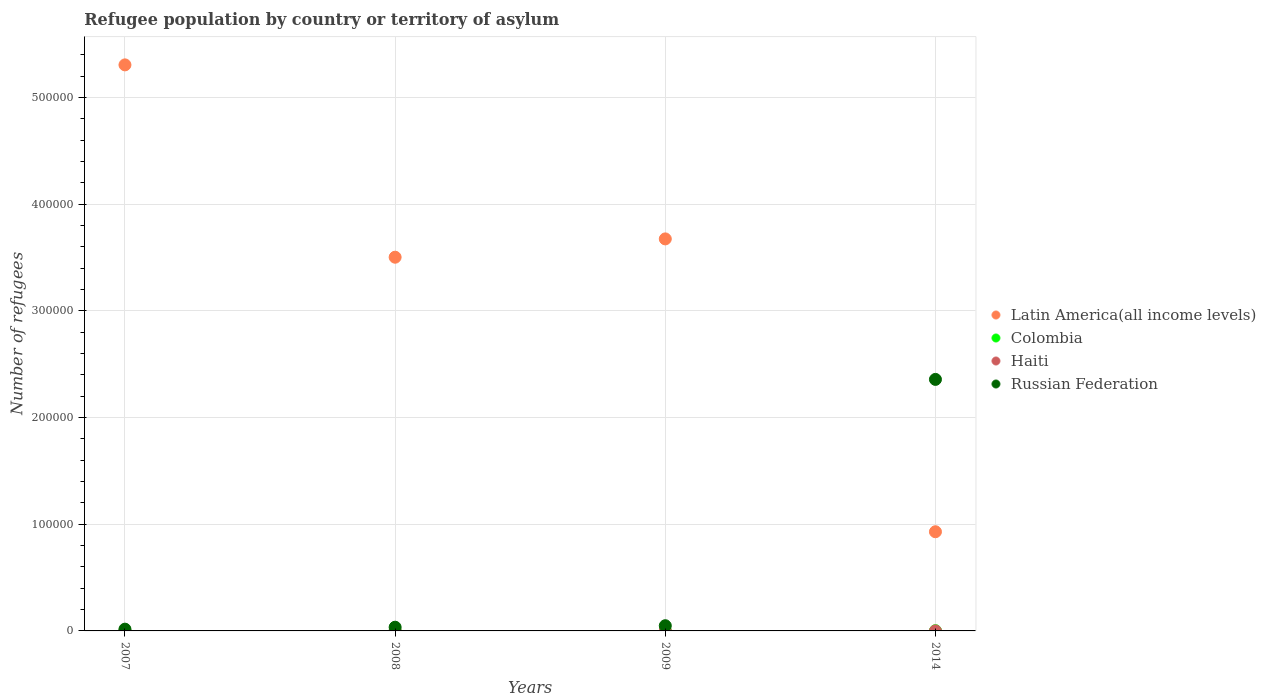How many different coloured dotlines are there?
Offer a very short reply. 4. What is the number of refugees in Latin America(all income levels) in 2008?
Ensure brevity in your answer.  3.50e+05. Across all years, what is the maximum number of refugees in Colombia?
Give a very brief answer. 213. In which year was the number of refugees in Haiti minimum?
Provide a short and direct response. 2007. What is the total number of refugees in Latin America(all income levels) in the graph?
Your response must be concise. 1.34e+06. What is the difference between the number of refugees in Colombia in 2007 and that in 2014?
Ensure brevity in your answer.  -45. What is the difference between the number of refugees in Colombia in 2008 and the number of refugees in Russian Federation in 2009?
Your answer should be very brief. -4710. What is the average number of refugees in Haiti per year?
Ensure brevity in your answer.  2.5. In the year 2007, what is the difference between the number of refugees in Latin America(all income levels) and number of refugees in Colombia?
Offer a very short reply. 5.30e+05. What is the ratio of the number of refugees in Colombia in 2008 to that in 2009?
Ensure brevity in your answer.  0.87. Is the number of refugees in Russian Federation in 2009 less than that in 2014?
Provide a succinct answer. Yes. What is the difference between the highest and the second highest number of refugees in Latin America(all income levels)?
Provide a succinct answer. 1.63e+05. What is the difference between the highest and the lowest number of refugees in Latin America(all income levels)?
Keep it short and to the point. 4.38e+05. In how many years, is the number of refugees in Russian Federation greater than the average number of refugees in Russian Federation taken over all years?
Make the answer very short. 1. Is the number of refugees in Colombia strictly less than the number of refugees in Latin America(all income levels) over the years?
Your response must be concise. Yes. How many dotlines are there?
Your answer should be compact. 4. Are the values on the major ticks of Y-axis written in scientific E-notation?
Your answer should be compact. No. How many legend labels are there?
Provide a succinct answer. 4. How are the legend labels stacked?
Offer a terse response. Vertical. What is the title of the graph?
Your response must be concise. Refugee population by country or territory of asylum. Does "Sri Lanka" appear as one of the legend labels in the graph?
Ensure brevity in your answer.  No. What is the label or title of the Y-axis?
Offer a very short reply. Number of refugees. What is the Number of refugees of Latin America(all income levels) in 2007?
Offer a terse response. 5.31e+05. What is the Number of refugees of Colombia in 2007?
Offer a very short reply. 168. What is the Number of refugees in Haiti in 2007?
Give a very brief answer. 1. What is the Number of refugees in Russian Federation in 2007?
Offer a very short reply. 1655. What is the Number of refugees in Latin America(all income levels) in 2008?
Your answer should be very brief. 3.50e+05. What is the Number of refugees of Colombia in 2008?
Make the answer very short. 170. What is the Number of refugees of Russian Federation in 2008?
Provide a succinct answer. 3479. What is the Number of refugees in Latin America(all income levels) in 2009?
Provide a succinct answer. 3.67e+05. What is the Number of refugees in Colombia in 2009?
Make the answer very short. 196. What is the Number of refugees of Russian Federation in 2009?
Make the answer very short. 4880. What is the Number of refugees in Latin America(all income levels) in 2014?
Offer a very short reply. 9.30e+04. What is the Number of refugees of Colombia in 2014?
Provide a succinct answer. 213. What is the Number of refugees in Haiti in 2014?
Make the answer very short. 3. What is the Number of refugees in Russian Federation in 2014?
Provide a succinct answer. 2.36e+05. Across all years, what is the maximum Number of refugees in Latin America(all income levels)?
Your answer should be compact. 5.31e+05. Across all years, what is the maximum Number of refugees of Colombia?
Make the answer very short. 213. Across all years, what is the maximum Number of refugees of Haiti?
Provide a succinct answer. 3. Across all years, what is the maximum Number of refugees in Russian Federation?
Your response must be concise. 2.36e+05. Across all years, what is the minimum Number of refugees in Latin America(all income levels)?
Provide a short and direct response. 9.30e+04. Across all years, what is the minimum Number of refugees of Colombia?
Offer a terse response. 168. Across all years, what is the minimum Number of refugees of Haiti?
Provide a short and direct response. 1. Across all years, what is the minimum Number of refugees of Russian Federation?
Keep it short and to the point. 1655. What is the total Number of refugees of Latin America(all income levels) in the graph?
Keep it short and to the point. 1.34e+06. What is the total Number of refugees in Colombia in the graph?
Your answer should be compact. 747. What is the total Number of refugees of Russian Federation in the graph?
Provide a short and direct response. 2.46e+05. What is the difference between the Number of refugees in Latin America(all income levels) in 2007 and that in 2008?
Make the answer very short. 1.80e+05. What is the difference between the Number of refugees in Haiti in 2007 and that in 2008?
Give a very brief answer. -2. What is the difference between the Number of refugees of Russian Federation in 2007 and that in 2008?
Make the answer very short. -1824. What is the difference between the Number of refugees of Latin America(all income levels) in 2007 and that in 2009?
Provide a succinct answer. 1.63e+05. What is the difference between the Number of refugees of Haiti in 2007 and that in 2009?
Offer a terse response. -2. What is the difference between the Number of refugees of Russian Federation in 2007 and that in 2009?
Make the answer very short. -3225. What is the difference between the Number of refugees in Latin America(all income levels) in 2007 and that in 2014?
Your answer should be compact. 4.38e+05. What is the difference between the Number of refugees of Colombia in 2007 and that in 2014?
Offer a very short reply. -45. What is the difference between the Number of refugees of Haiti in 2007 and that in 2014?
Your answer should be compact. -2. What is the difference between the Number of refugees in Russian Federation in 2007 and that in 2014?
Provide a succinct answer. -2.34e+05. What is the difference between the Number of refugees in Latin America(all income levels) in 2008 and that in 2009?
Keep it short and to the point. -1.72e+04. What is the difference between the Number of refugees of Haiti in 2008 and that in 2009?
Your answer should be compact. 0. What is the difference between the Number of refugees in Russian Federation in 2008 and that in 2009?
Make the answer very short. -1401. What is the difference between the Number of refugees in Latin America(all income levels) in 2008 and that in 2014?
Your answer should be very brief. 2.57e+05. What is the difference between the Number of refugees in Colombia in 2008 and that in 2014?
Offer a very short reply. -43. What is the difference between the Number of refugees of Russian Federation in 2008 and that in 2014?
Make the answer very short. -2.32e+05. What is the difference between the Number of refugees in Latin America(all income levels) in 2009 and that in 2014?
Provide a succinct answer. 2.74e+05. What is the difference between the Number of refugees in Colombia in 2009 and that in 2014?
Your response must be concise. -17. What is the difference between the Number of refugees in Russian Federation in 2009 and that in 2014?
Keep it short and to the point. -2.31e+05. What is the difference between the Number of refugees of Latin America(all income levels) in 2007 and the Number of refugees of Colombia in 2008?
Your answer should be very brief. 5.30e+05. What is the difference between the Number of refugees of Latin America(all income levels) in 2007 and the Number of refugees of Haiti in 2008?
Your answer should be very brief. 5.31e+05. What is the difference between the Number of refugees of Latin America(all income levels) in 2007 and the Number of refugees of Russian Federation in 2008?
Your answer should be very brief. 5.27e+05. What is the difference between the Number of refugees in Colombia in 2007 and the Number of refugees in Haiti in 2008?
Give a very brief answer. 165. What is the difference between the Number of refugees in Colombia in 2007 and the Number of refugees in Russian Federation in 2008?
Your response must be concise. -3311. What is the difference between the Number of refugees in Haiti in 2007 and the Number of refugees in Russian Federation in 2008?
Your response must be concise. -3478. What is the difference between the Number of refugees of Latin America(all income levels) in 2007 and the Number of refugees of Colombia in 2009?
Your response must be concise. 5.30e+05. What is the difference between the Number of refugees of Latin America(all income levels) in 2007 and the Number of refugees of Haiti in 2009?
Provide a succinct answer. 5.31e+05. What is the difference between the Number of refugees in Latin America(all income levels) in 2007 and the Number of refugees in Russian Federation in 2009?
Keep it short and to the point. 5.26e+05. What is the difference between the Number of refugees in Colombia in 2007 and the Number of refugees in Haiti in 2009?
Provide a short and direct response. 165. What is the difference between the Number of refugees of Colombia in 2007 and the Number of refugees of Russian Federation in 2009?
Your answer should be compact. -4712. What is the difference between the Number of refugees of Haiti in 2007 and the Number of refugees of Russian Federation in 2009?
Make the answer very short. -4879. What is the difference between the Number of refugees of Latin America(all income levels) in 2007 and the Number of refugees of Colombia in 2014?
Make the answer very short. 5.30e+05. What is the difference between the Number of refugees in Latin America(all income levels) in 2007 and the Number of refugees in Haiti in 2014?
Make the answer very short. 5.31e+05. What is the difference between the Number of refugees of Latin America(all income levels) in 2007 and the Number of refugees of Russian Federation in 2014?
Make the answer very short. 2.95e+05. What is the difference between the Number of refugees of Colombia in 2007 and the Number of refugees of Haiti in 2014?
Provide a short and direct response. 165. What is the difference between the Number of refugees in Colombia in 2007 and the Number of refugees in Russian Federation in 2014?
Offer a very short reply. -2.36e+05. What is the difference between the Number of refugees of Haiti in 2007 and the Number of refugees of Russian Federation in 2014?
Give a very brief answer. -2.36e+05. What is the difference between the Number of refugees of Latin America(all income levels) in 2008 and the Number of refugees of Colombia in 2009?
Ensure brevity in your answer.  3.50e+05. What is the difference between the Number of refugees of Latin America(all income levels) in 2008 and the Number of refugees of Haiti in 2009?
Provide a short and direct response. 3.50e+05. What is the difference between the Number of refugees of Latin America(all income levels) in 2008 and the Number of refugees of Russian Federation in 2009?
Ensure brevity in your answer.  3.45e+05. What is the difference between the Number of refugees of Colombia in 2008 and the Number of refugees of Haiti in 2009?
Ensure brevity in your answer.  167. What is the difference between the Number of refugees of Colombia in 2008 and the Number of refugees of Russian Federation in 2009?
Your answer should be very brief. -4710. What is the difference between the Number of refugees of Haiti in 2008 and the Number of refugees of Russian Federation in 2009?
Offer a terse response. -4877. What is the difference between the Number of refugees of Latin America(all income levels) in 2008 and the Number of refugees of Colombia in 2014?
Provide a succinct answer. 3.50e+05. What is the difference between the Number of refugees in Latin America(all income levels) in 2008 and the Number of refugees in Haiti in 2014?
Give a very brief answer. 3.50e+05. What is the difference between the Number of refugees of Latin America(all income levels) in 2008 and the Number of refugees of Russian Federation in 2014?
Provide a short and direct response. 1.15e+05. What is the difference between the Number of refugees in Colombia in 2008 and the Number of refugees in Haiti in 2014?
Provide a succinct answer. 167. What is the difference between the Number of refugees of Colombia in 2008 and the Number of refugees of Russian Federation in 2014?
Give a very brief answer. -2.36e+05. What is the difference between the Number of refugees in Haiti in 2008 and the Number of refugees in Russian Federation in 2014?
Your answer should be very brief. -2.36e+05. What is the difference between the Number of refugees of Latin America(all income levels) in 2009 and the Number of refugees of Colombia in 2014?
Offer a terse response. 3.67e+05. What is the difference between the Number of refugees in Latin America(all income levels) in 2009 and the Number of refugees in Haiti in 2014?
Your answer should be very brief. 3.67e+05. What is the difference between the Number of refugees in Latin America(all income levels) in 2009 and the Number of refugees in Russian Federation in 2014?
Give a very brief answer. 1.32e+05. What is the difference between the Number of refugees of Colombia in 2009 and the Number of refugees of Haiti in 2014?
Your answer should be compact. 193. What is the difference between the Number of refugees in Colombia in 2009 and the Number of refugees in Russian Federation in 2014?
Provide a succinct answer. -2.36e+05. What is the difference between the Number of refugees of Haiti in 2009 and the Number of refugees of Russian Federation in 2014?
Provide a succinct answer. -2.36e+05. What is the average Number of refugees of Latin America(all income levels) per year?
Offer a terse response. 3.35e+05. What is the average Number of refugees of Colombia per year?
Provide a succinct answer. 186.75. What is the average Number of refugees in Russian Federation per year?
Give a very brief answer. 6.14e+04. In the year 2007, what is the difference between the Number of refugees in Latin America(all income levels) and Number of refugees in Colombia?
Your answer should be very brief. 5.30e+05. In the year 2007, what is the difference between the Number of refugees of Latin America(all income levels) and Number of refugees of Haiti?
Give a very brief answer. 5.31e+05. In the year 2007, what is the difference between the Number of refugees of Latin America(all income levels) and Number of refugees of Russian Federation?
Provide a short and direct response. 5.29e+05. In the year 2007, what is the difference between the Number of refugees in Colombia and Number of refugees in Haiti?
Give a very brief answer. 167. In the year 2007, what is the difference between the Number of refugees in Colombia and Number of refugees in Russian Federation?
Your answer should be compact. -1487. In the year 2007, what is the difference between the Number of refugees in Haiti and Number of refugees in Russian Federation?
Offer a very short reply. -1654. In the year 2008, what is the difference between the Number of refugees of Latin America(all income levels) and Number of refugees of Colombia?
Your answer should be compact. 3.50e+05. In the year 2008, what is the difference between the Number of refugees in Latin America(all income levels) and Number of refugees in Haiti?
Make the answer very short. 3.50e+05. In the year 2008, what is the difference between the Number of refugees of Latin America(all income levels) and Number of refugees of Russian Federation?
Ensure brevity in your answer.  3.47e+05. In the year 2008, what is the difference between the Number of refugees in Colombia and Number of refugees in Haiti?
Keep it short and to the point. 167. In the year 2008, what is the difference between the Number of refugees of Colombia and Number of refugees of Russian Federation?
Keep it short and to the point. -3309. In the year 2008, what is the difference between the Number of refugees of Haiti and Number of refugees of Russian Federation?
Your response must be concise. -3476. In the year 2009, what is the difference between the Number of refugees of Latin America(all income levels) and Number of refugees of Colombia?
Make the answer very short. 3.67e+05. In the year 2009, what is the difference between the Number of refugees in Latin America(all income levels) and Number of refugees in Haiti?
Provide a succinct answer. 3.67e+05. In the year 2009, what is the difference between the Number of refugees in Latin America(all income levels) and Number of refugees in Russian Federation?
Keep it short and to the point. 3.63e+05. In the year 2009, what is the difference between the Number of refugees of Colombia and Number of refugees of Haiti?
Provide a succinct answer. 193. In the year 2009, what is the difference between the Number of refugees of Colombia and Number of refugees of Russian Federation?
Your answer should be compact. -4684. In the year 2009, what is the difference between the Number of refugees of Haiti and Number of refugees of Russian Federation?
Your response must be concise. -4877. In the year 2014, what is the difference between the Number of refugees in Latin America(all income levels) and Number of refugees in Colombia?
Keep it short and to the point. 9.27e+04. In the year 2014, what is the difference between the Number of refugees in Latin America(all income levels) and Number of refugees in Haiti?
Your answer should be compact. 9.30e+04. In the year 2014, what is the difference between the Number of refugees in Latin America(all income levels) and Number of refugees in Russian Federation?
Give a very brief answer. -1.43e+05. In the year 2014, what is the difference between the Number of refugees of Colombia and Number of refugees of Haiti?
Your response must be concise. 210. In the year 2014, what is the difference between the Number of refugees in Colombia and Number of refugees in Russian Federation?
Provide a succinct answer. -2.36e+05. In the year 2014, what is the difference between the Number of refugees in Haiti and Number of refugees in Russian Federation?
Your answer should be very brief. -2.36e+05. What is the ratio of the Number of refugees in Latin America(all income levels) in 2007 to that in 2008?
Make the answer very short. 1.51. What is the ratio of the Number of refugees in Colombia in 2007 to that in 2008?
Offer a terse response. 0.99. What is the ratio of the Number of refugees of Haiti in 2007 to that in 2008?
Your answer should be very brief. 0.33. What is the ratio of the Number of refugees of Russian Federation in 2007 to that in 2008?
Make the answer very short. 0.48. What is the ratio of the Number of refugees in Latin America(all income levels) in 2007 to that in 2009?
Provide a short and direct response. 1.44. What is the ratio of the Number of refugees of Haiti in 2007 to that in 2009?
Ensure brevity in your answer.  0.33. What is the ratio of the Number of refugees of Russian Federation in 2007 to that in 2009?
Your answer should be compact. 0.34. What is the ratio of the Number of refugees of Latin America(all income levels) in 2007 to that in 2014?
Your response must be concise. 5.71. What is the ratio of the Number of refugees of Colombia in 2007 to that in 2014?
Provide a succinct answer. 0.79. What is the ratio of the Number of refugees in Haiti in 2007 to that in 2014?
Keep it short and to the point. 0.33. What is the ratio of the Number of refugees of Russian Federation in 2007 to that in 2014?
Provide a succinct answer. 0.01. What is the ratio of the Number of refugees in Latin America(all income levels) in 2008 to that in 2009?
Your answer should be very brief. 0.95. What is the ratio of the Number of refugees of Colombia in 2008 to that in 2009?
Make the answer very short. 0.87. What is the ratio of the Number of refugees in Russian Federation in 2008 to that in 2009?
Give a very brief answer. 0.71. What is the ratio of the Number of refugees of Latin America(all income levels) in 2008 to that in 2014?
Offer a terse response. 3.77. What is the ratio of the Number of refugees of Colombia in 2008 to that in 2014?
Your response must be concise. 0.8. What is the ratio of the Number of refugees of Haiti in 2008 to that in 2014?
Keep it short and to the point. 1. What is the ratio of the Number of refugees of Russian Federation in 2008 to that in 2014?
Ensure brevity in your answer.  0.01. What is the ratio of the Number of refugees of Latin America(all income levels) in 2009 to that in 2014?
Your response must be concise. 3.95. What is the ratio of the Number of refugees of Colombia in 2009 to that in 2014?
Your response must be concise. 0.92. What is the ratio of the Number of refugees in Haiti in 2009 to that in 2014?
Keep it short and to the point. 1. What is the ratio of the Number of refugees of Russian Federation in 2009 to that in 2014?
Your answer should be compact. 0.02. What is the difference between the highest and the second highest Number of refugees of Latin America(all income levels)?
Make the answer very short. 1.63e+05. What is the difference between the highest and the second highest Number of refugees in Haiti?
Offer a terse response. 0. What is the difference between the highest and the second highest Number of refugees in Russian Federation?
Make the answer very short. 2.31e+05. What is the difference between the highest and the lowest Number of refugees of Latin America(all income levels)?
Keep it short and to the point. 4.38e+05. What is the difference between the highest and the lowest Number of refugees in Colombia?
Provide a short and direct response. 45. What is the difference between the highest and the lowest Number of refugees in Haiti?
Give a very brief answer. 2. What is the difference between the highest and the lowest Number of refugees of Russian Federation?
Make the answer very short. 2.34e+05. 